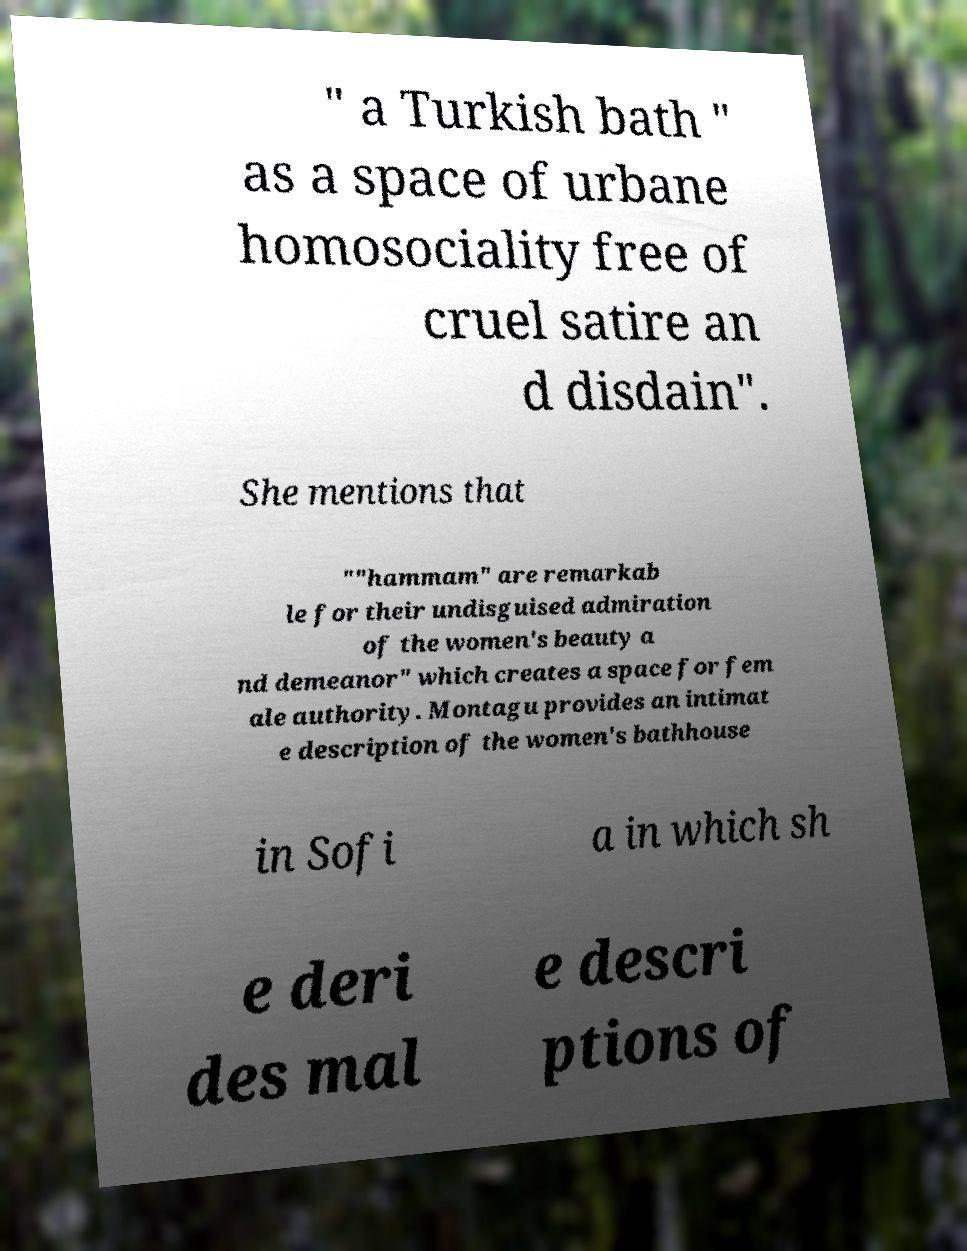Can you accurately transcribe the text from the provided image for me? " a Turkish bath " as a space of urbane homosociality free of cruel satire an d disdain". She mentions that ""hammam" are remarkab le for their undisguised admiration of the women's beauty a nd demeanor" which creates a space for fem ale authority. Montagu provides an intimat e description of the women's bathhouse in Sofi a in which sh e deri des mal e descri ptions of 